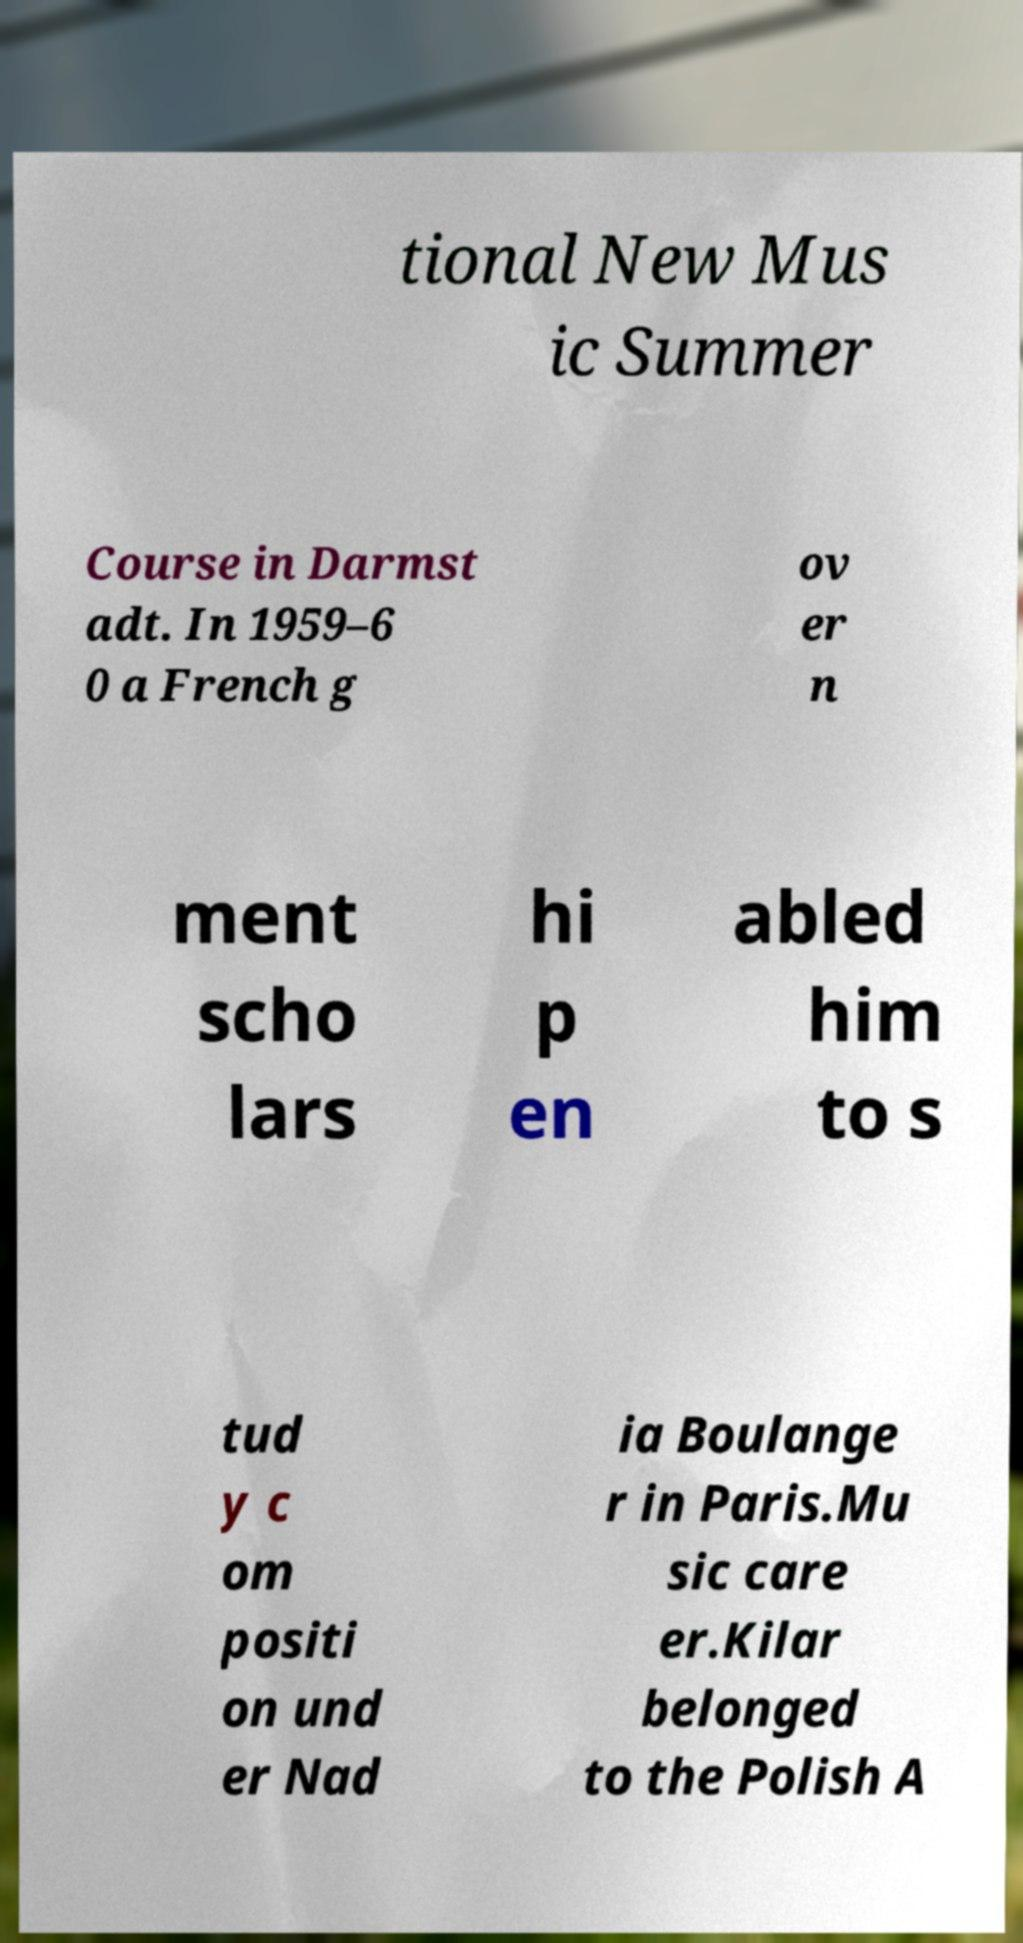Please identify and transcribe the text found in this image. tional New Mus ic Summer Course in Darmst adt. In 1959–6 0 a French g ov er n ment scho lars hi p en abled him to s tud y c om positi on und er Nad ia Boulange r in Paris.Mu sic care er.Kilar belonged to the Polish A 